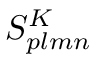<formula> <loc_0><loc_0><loc_500><loc_500>S _ { p l m n } ^ { K }</formula> 